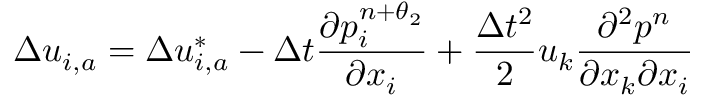Convert formula to latex. <formula><loc_0><loc_0><loc_500><loc_500>\Delta { { u } _ { i , a } } = \Delta u _ { i , a } ^ { * } - \Delta t \frac { \partial p _ { i } ^ { n + { { \theta } _ { 2 } } } } { \partial { { x } _ { i } } } + \frac { \Delta { { t } ^ { 2 } } } { 2 } { { u } _ { k } } \frac { { { \partial } ^ { 2 } } { { p } ^ { n } } } { \partial { { x } _ { k } } \partial { { x } _ { i } } }</formula> 